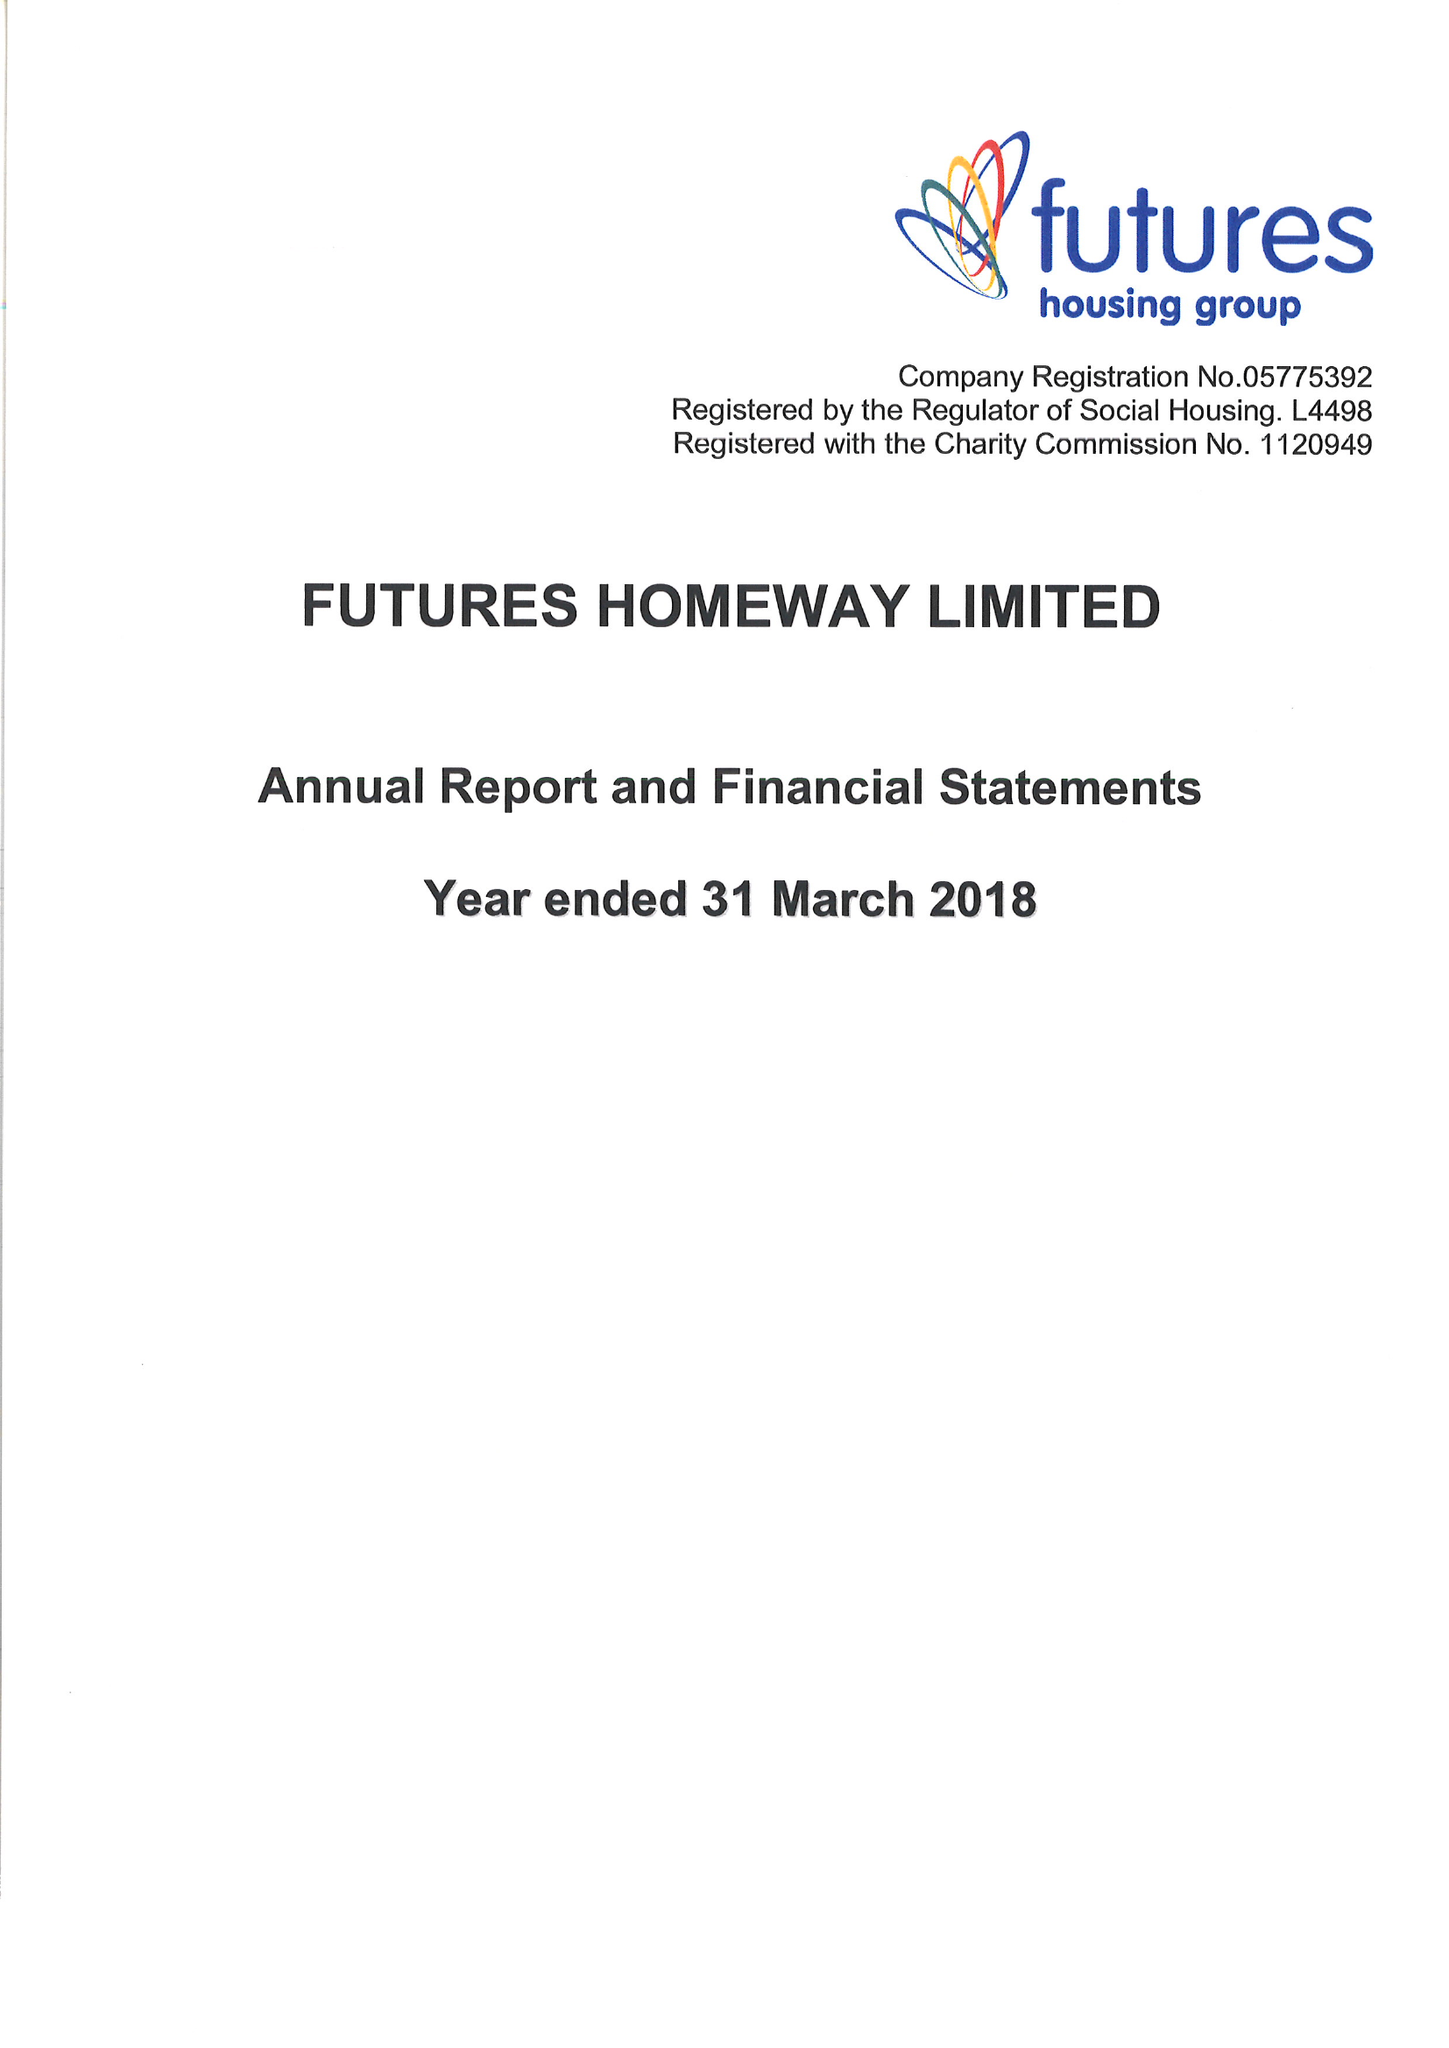What is the value for the charity_name?
Answer the question using a single word or phrase. Futures Homeway Ltd. 